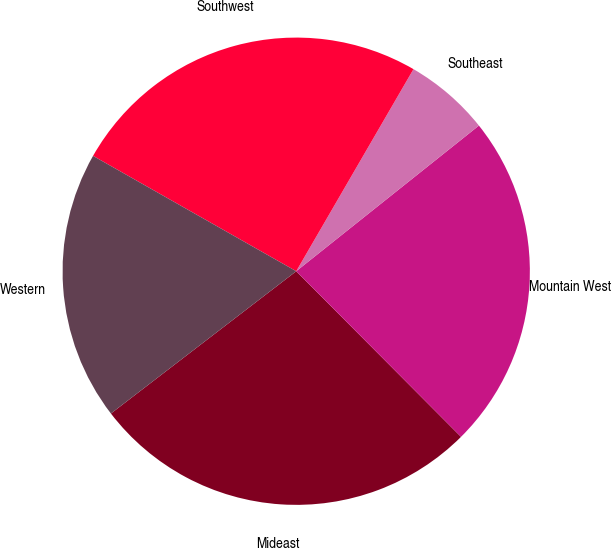Convert chart. <chart><loc_0><loc_0><loc_500><loc_500><pie_chart><fcel>Mideast<fcel>Mountain West<fcel>Southeast<fcel>Southwest<fcel>Western<nl><fcel>27.04%<fcel>23.25%<fcel>5.92%<fcel>25.15%<fcel>18.64%<nl></chart> 